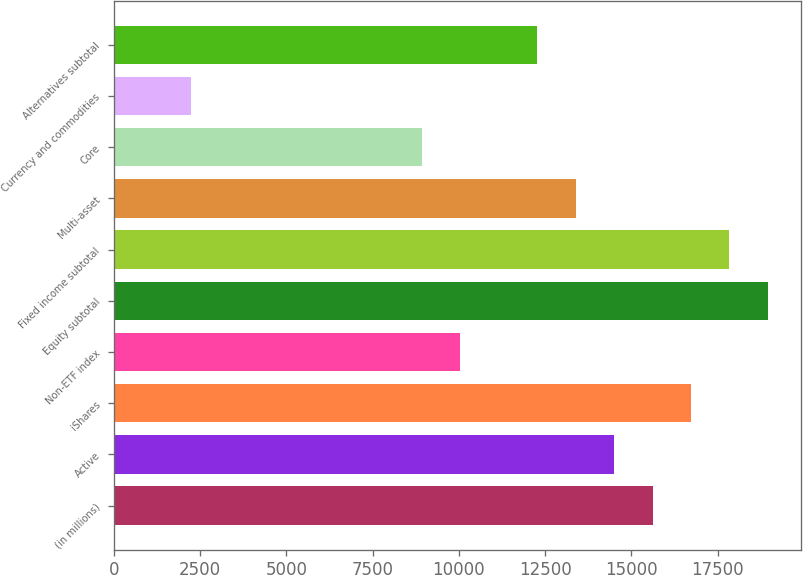<chart> <loc_0><loc_0><loc_500><loc_500><bar_chart><fcel>(in millions)<fcel>Active<fcel>iShares<fcel>Non-ETF index<fcel>Equity subtotal<fcel>Fixed income subtotal<fcel>Multi-asset<fcel>Core<fcel>Currency and commodities<fcel>Alternatives subtotal<nl><fcel>15611.8<fcel>14497.6<fcel>16726<fcel>10040.8<fcel>18954.4<fcel>17840.2<fcel>13383.4<fcel>8926.6<fcel>2241.4<fcel>12269.2<nl></chart> 